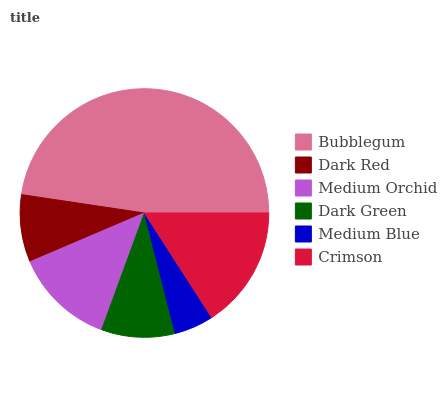Is Medium Blue the minimum?
Answer yes or no. Yes. Is Bubblegum the maximum?
Answer yes or no. Yes. Is Dark Red the minimum?
Answer yes or no. No. Is Dark Red the maximum?
Answer yes or no. No. Is Bubblegum greater than Dark Red?
Answer yes or no. Yes. Is Dark Red less than Bubblegum?
Answer yes or no. Yes. Is Dark Red greater than Bubblegum?
Answer yes or no. No. Is Bubblegum less than Dark Red?
Answer yes or no. No. Is Medium Orchid the high median?
Answer yes or no. Yes. Is Dark Green the low median?
Answer yes or no. Yes. Is Medium Blue the high median?
Answer yes or no. No. Is Crimson the low median?
Answer yes or no. No. 